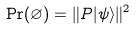<formula> <loc_0><loc_0><loc_500><loc_500>\Pr ( \varnothing ) = \| P | \psi \rangle \| ^ { 2 }</formula> 